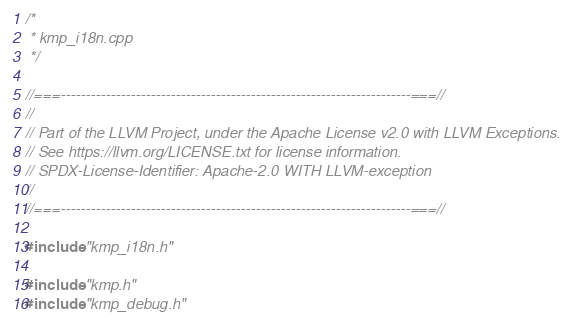Convert code to text. <code><loc_0><loc_0><loc_500><loc_500><_C++_>/*
 * kmp_i18n.cpp
 */

//===----------------------------------------------------------------------===//
//
// Part of the LLVM Project, under the Apache License v2.0 with LLVM Exceptions.
// See https://llvm.org/LICENSE.txt for license information.
// SPDX-License-Identifier: Apache-2.0 WITH LLVM-exception
//
//===----------------------------------------------------------------------===//

#include "kmp_i18n.h"

#include "kmp.h"
#include "kmp_debug.h"</code> 